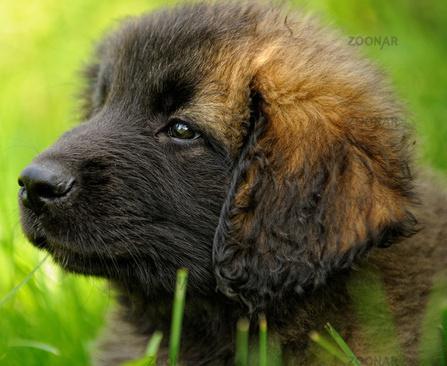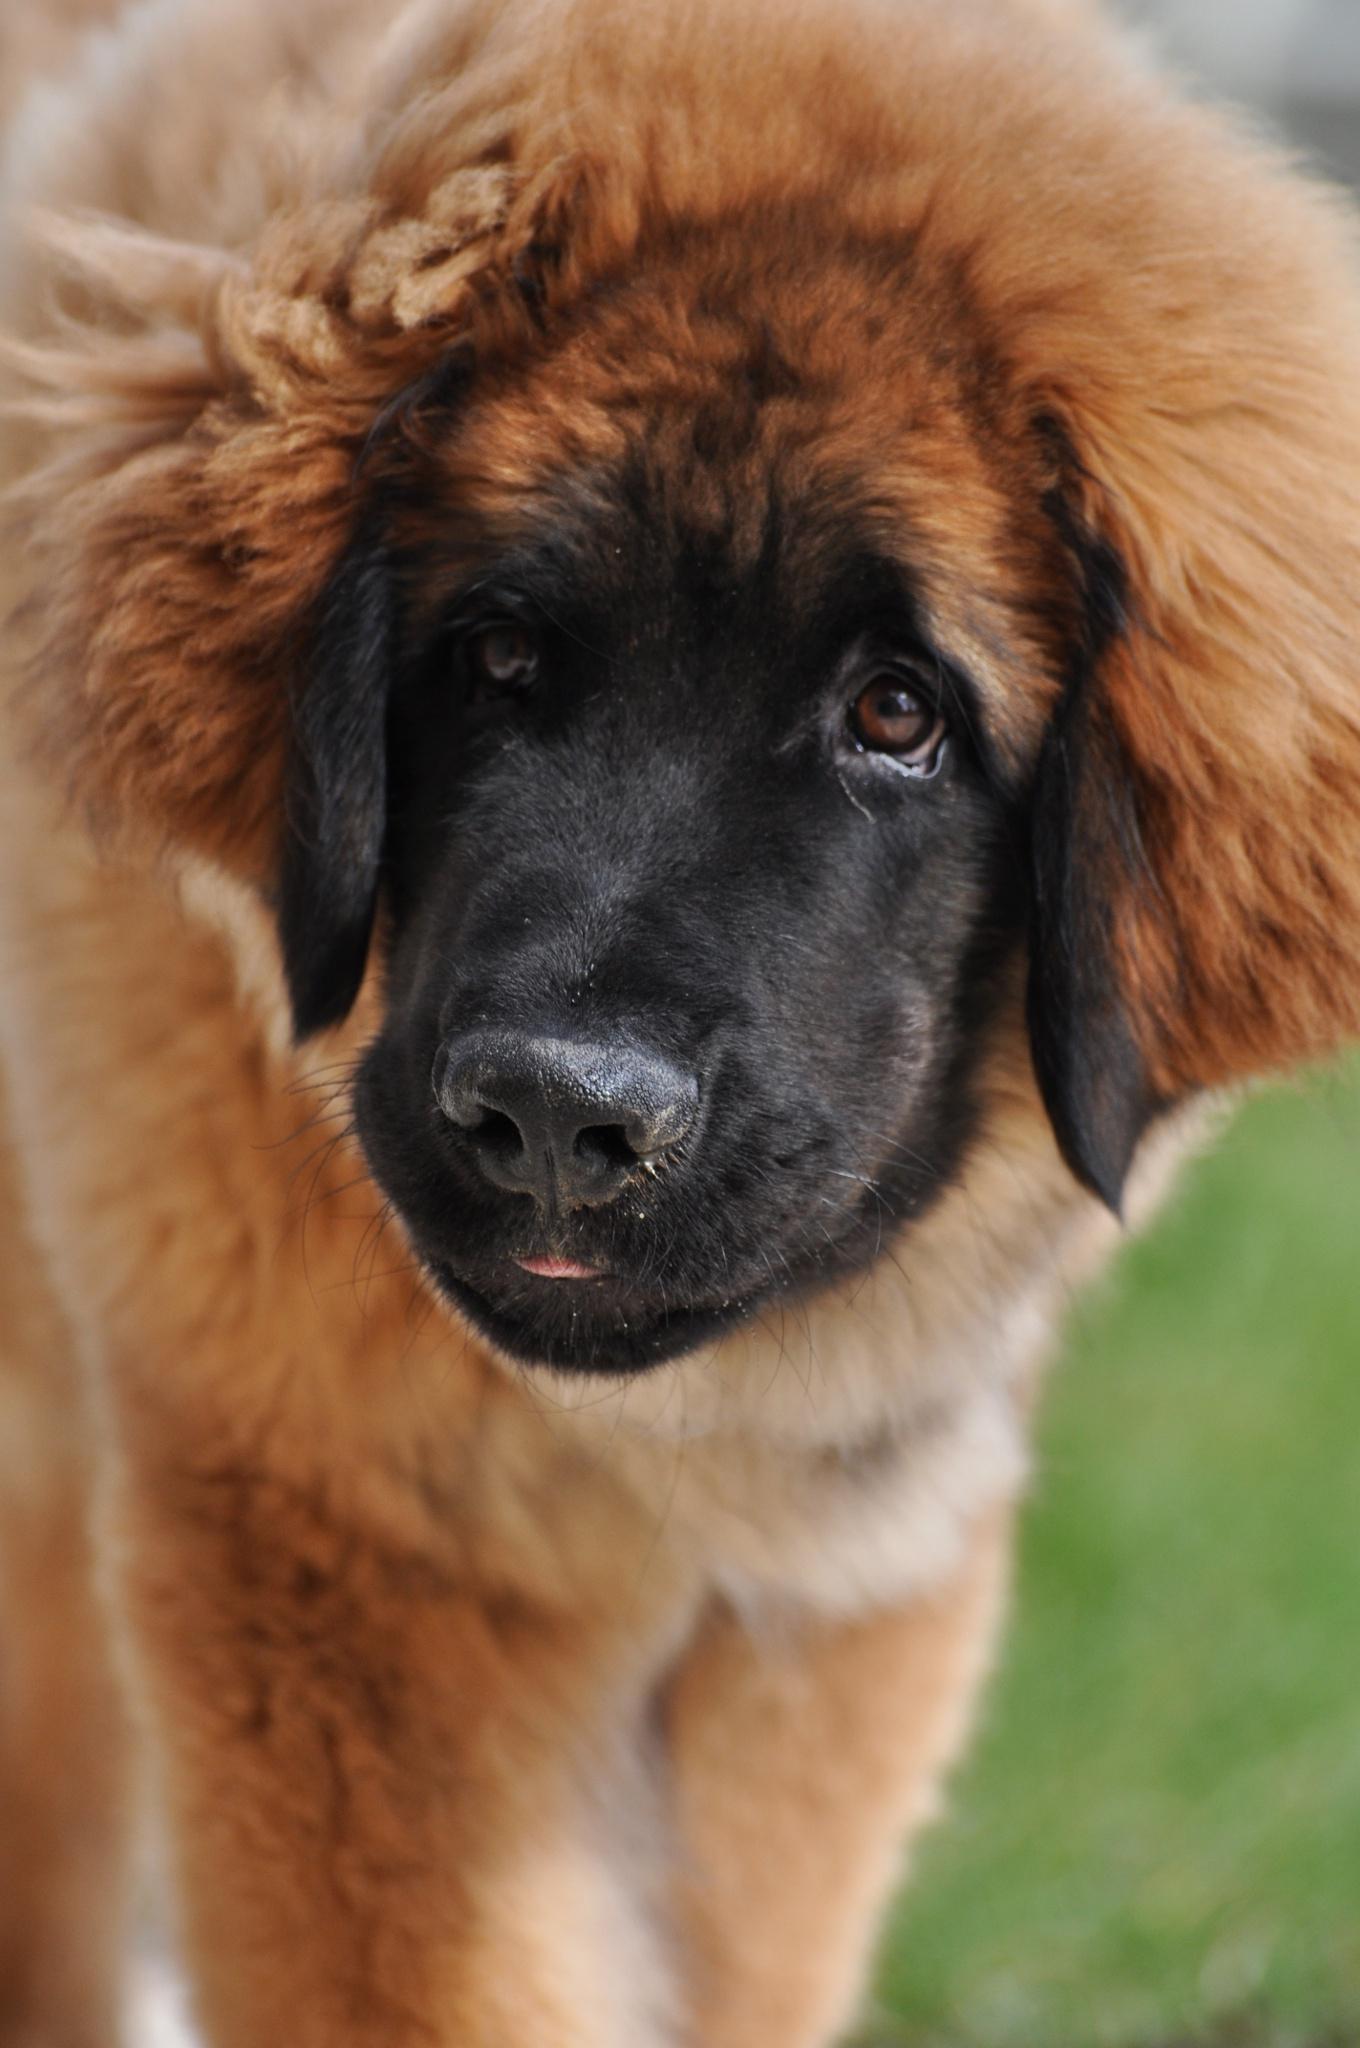The first image is the image on the left, the second image is the image on the right. Assess this claim about the two images: "Both dogs are outside on the grass.". Correct or not? Answer yes or no. Yes. The first image is the image on the left, the second image is the image on the right. Evaluate the accuracy of this statement regarding the images: "Right image shows one furry dog in an outdoor area enclosed by wire.". Is it true? Answer yes or no. No. 